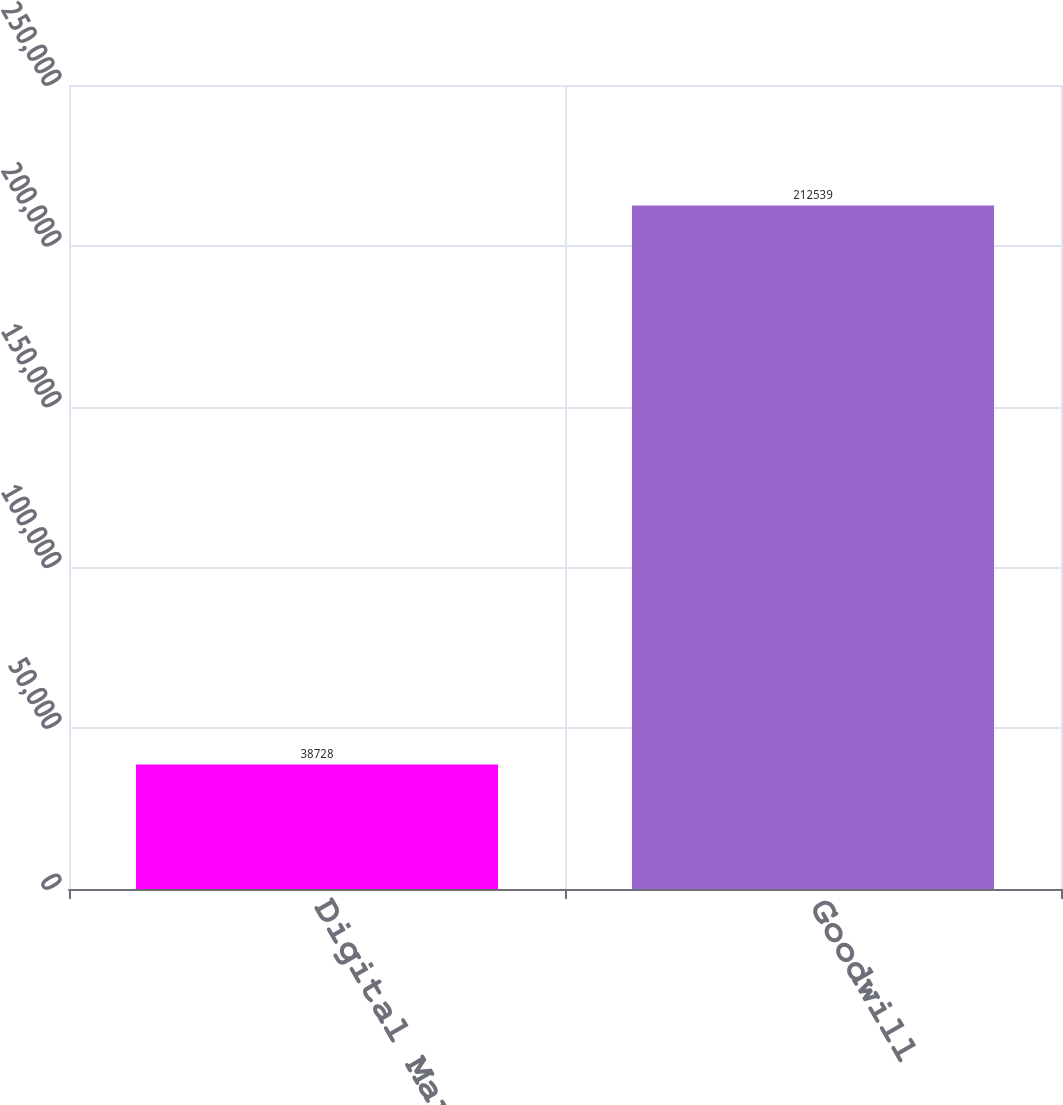Convert chart to OTSL. <chart><loc_0><loc_0><loc_500><loc_500><bar_chart><fcel>Digital Marketing<fcel>Goodwill<nl><fcel>38728<fcel>212539<nl></chart> 